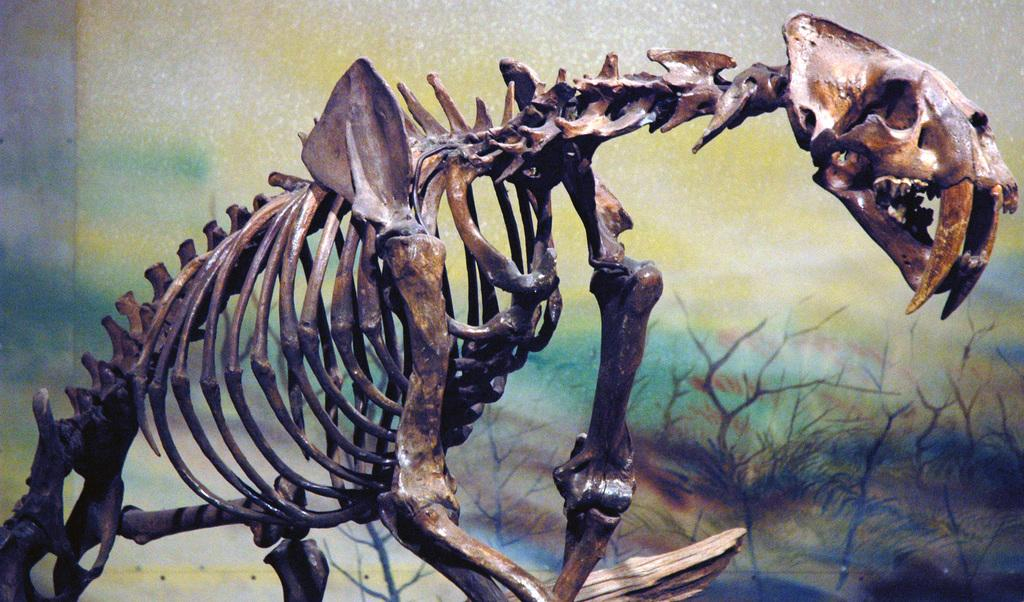What is the main subject of the image? The main subject of the image is a skeleton of an animal. What can be seen behind the skeleton? There is a wall behind the skeleton. What is on the wall in the image? There is a painting on the wall. What type of rhythm can be heard coming from the skeleton in the image? There is no sound or rhythm associated with the skeleton in the image; it is a static representation of an animal's skeleton. 